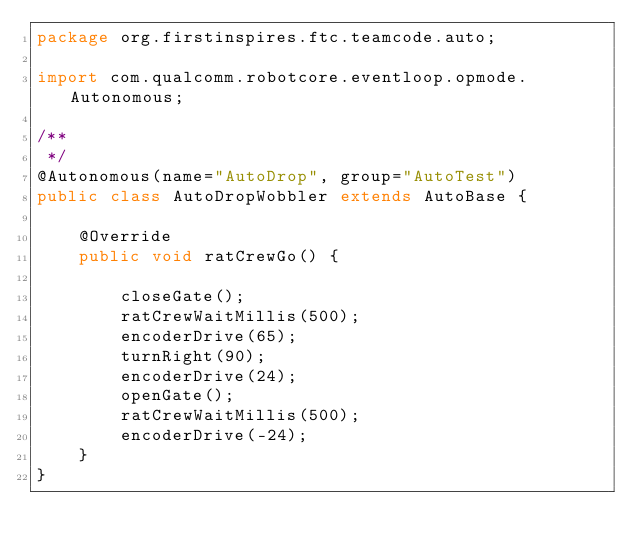<code> <loc_0><loc_0><loc_500><loc_500><_Java_>package org.firstinspires.ftc.teamcode.auto;

import com.qualcomm.robotcore.eventloop.opmode.Autonomous;

/**
 */
@Autonomous(name="AutoDrop", group="AutoTest")
public class AutoDropWobbler extends AutoBase {

    @Override
    public void ratCrewGo() {

        closeGate();
        ratCrewWaitMillis(500);
        encoderDrive(65);
        turnRight(90);
        encoderDrive(24);
        openGate();
        ratCrewWaitMillis(500);
        encoderDrive(-24);
    }
}
</code> 